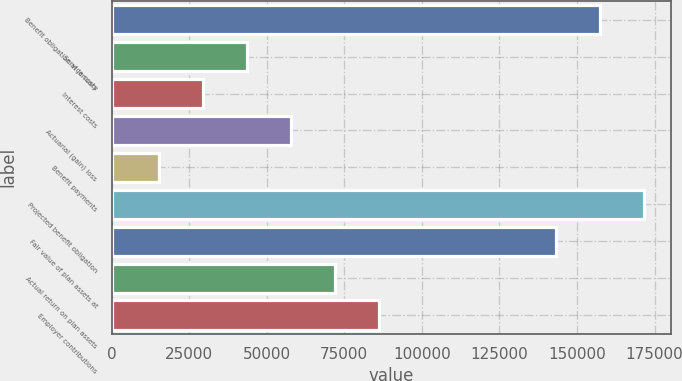Convert chart. <chart><loc_0><loc_0><loc_500><loc_500><bar_chart><fcel>Benefit obligation at January<fcel>Service costs<fcel>Interest costs<fcel>Actuarial (gain) loss<fcel>Benefit payments<fcel>Projected benefit obligation<fcel>Fair value of plan assets at<fcel>Actual return on plan assets<fcel>Employer contributions<nl><fcel>157376<fcel>43629.9<fcel>29411.6<fcel>57848.2<fcel>15193.3<fcel>171595<fcel>143158<fcel>72066.5<fcel>86284.8<nl></chart> 